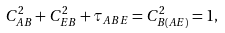<formula> <loc_0><loc_0><loc_500><loc_500>C _ { A B } ^ { 2 } + C _ { E B } ^ { 2 } + \tau _ { A B E } = C ^ { 2 } _ { B ( A E ) } = 1 ,</formula> 